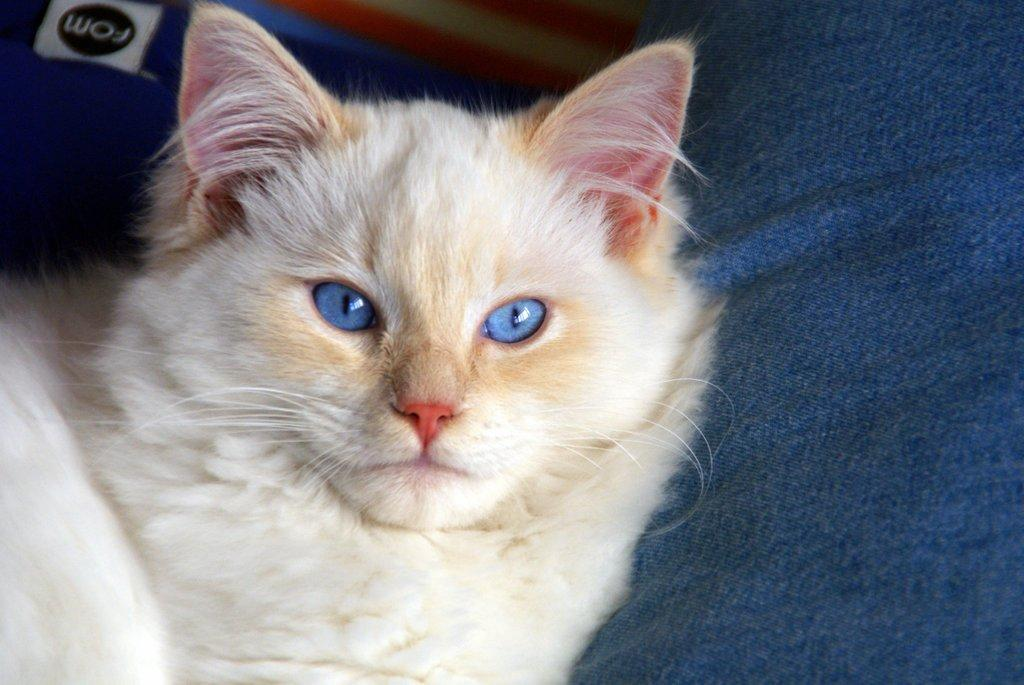What type of animal is in the image? There is a cat in the image. Can you describe the color of the cat? The cat is white and cream in color. What other object can be seen in the image? There is a blue color cloth in the image. What else is visible in the image besides the cat and the cloth? There are alphabets visible in the image. What type of fish can be seen swimming in the image? There is no fish present in the image; it features a cat and a blue color cloth with alphabets. 